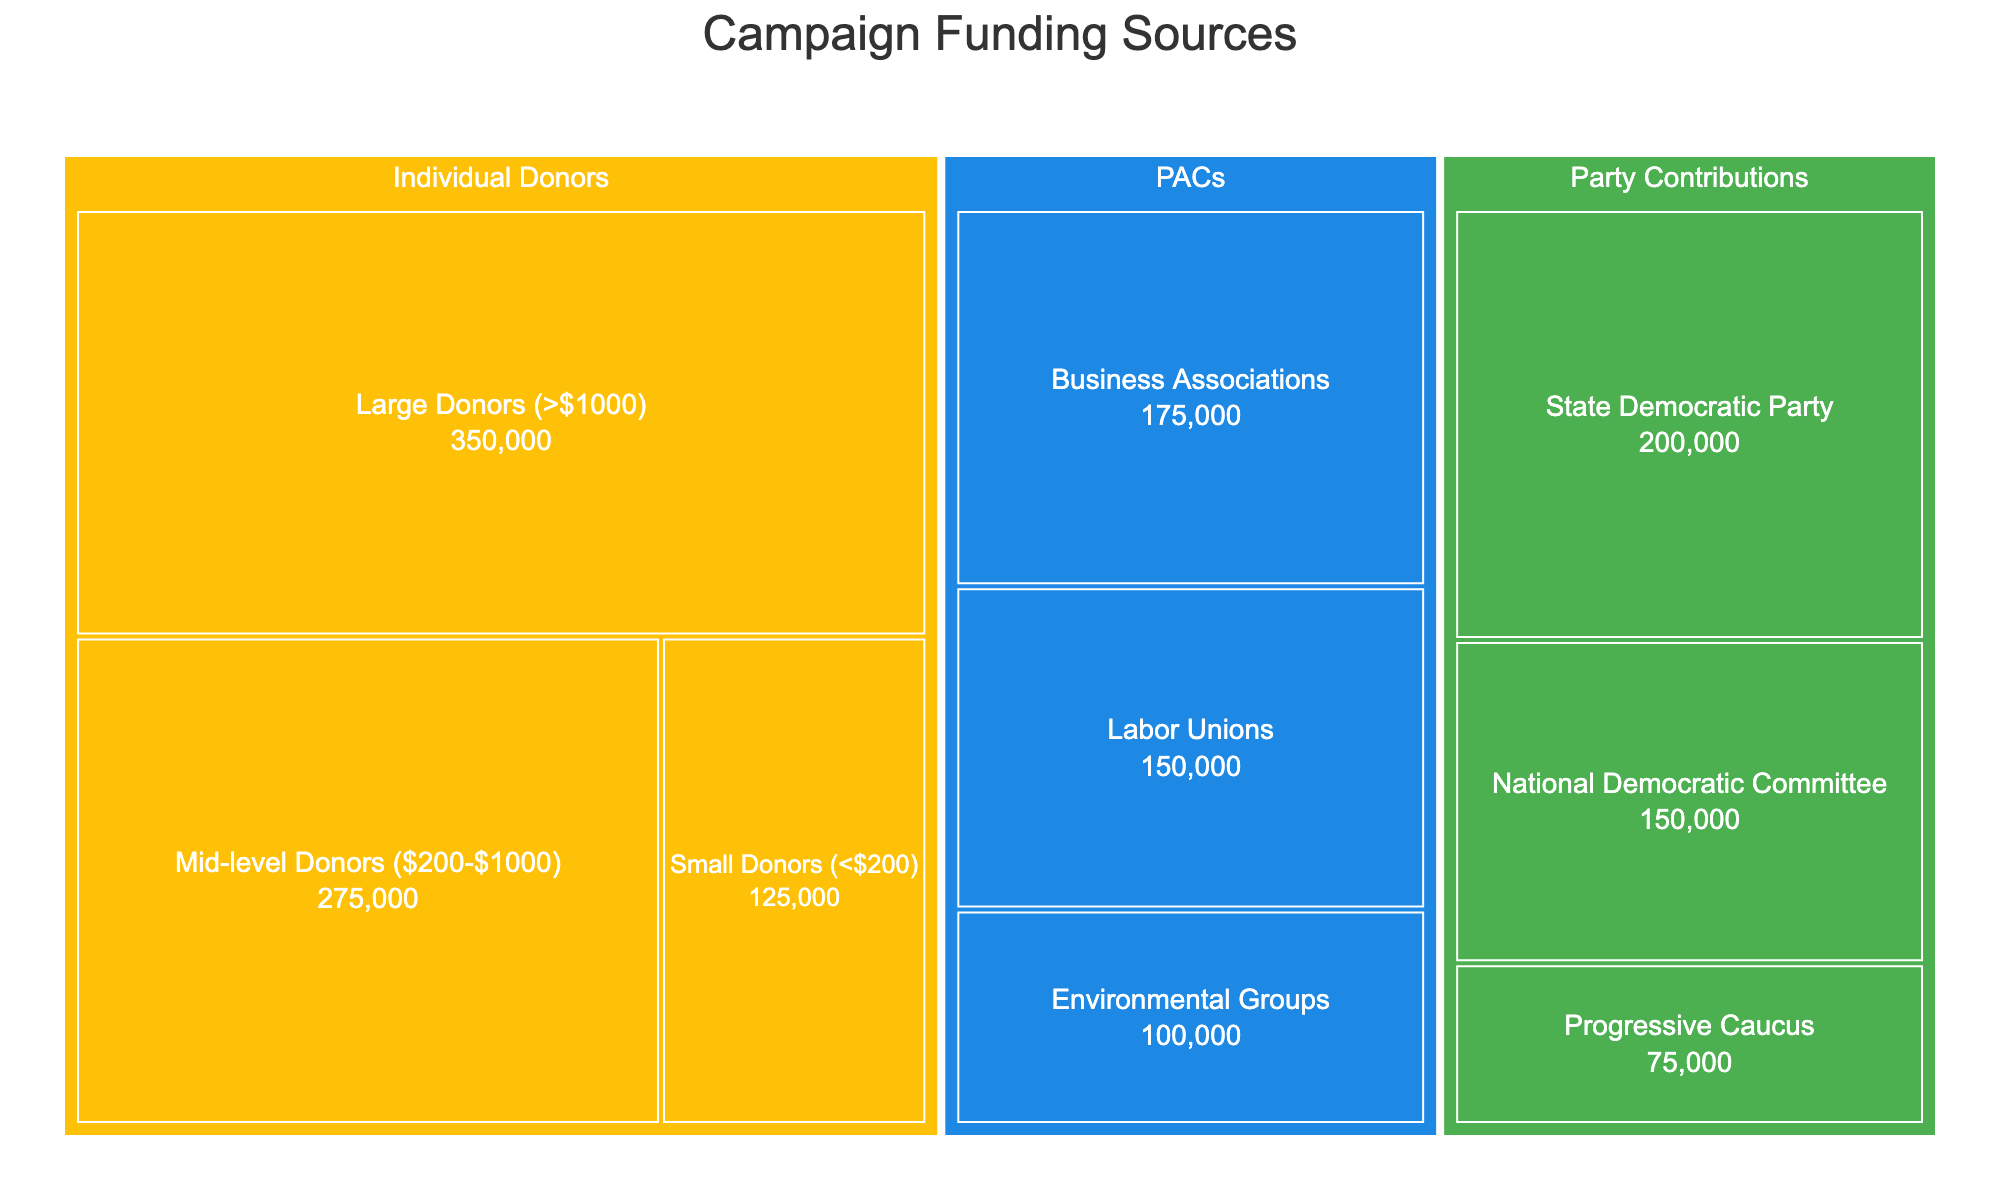Which category has the highest total funding? Summing the amounts in each category:
Individual Donors: 125000 + 275000 + 350000 = 750000
PACs: 150000 + 100000 + 175000 = 425000
Party Contributions: 200000 + 150000 + 75000 = 425000
Individual Donors have the highest total funding.
Answer: Individual Donors How much funding does the subcategory with the lowest amount receive? The subcategories and their amounts are:
Small Donors (<$200): 125000
Mid-level Donors ($200-$1000): 275000
Large Donors (>$1000): 350000
Labor Unions: 150000
Environmental Groups: 100000
Business Associations: 175000
State Democratic Party: 200000
National Democratic Committee: 150000
Progressive Caucus: 75000
Environmental Groups receive the lowest amount, which is $75,000.
Answer: $75,000 What is the combined funding from PACs and Party Contributions categories? Sum the totals for PACs and Party Contributions:
PACs: 150000 + 100000 + 175000 = 425000
Party Contributions: 200000 + 150000 + 75000 = 425000
Add these together: 425000 + 425000 = 850000.
Answer: $850,000 Which PAC subcategory contributes the most? The subcategories and their amounts are:
Labor Unions: 150000
Environmental Groups: 100000
Business Associations: 175000
Business Associations is the PAC subcategory that contributes the most at $175,000.
Answer: Business Associations How does the combined amount from Individual Donors compare to total Party Contributions? Total Individual Donors: 125000 + 275000 + 350000 = 750000
Party Contributions: 200000 + 150000 + 75000 = 425000
Individual Donors have more funding: 750000 > 425000
Answer: Individual Donors have more funding What's the proportion of State Democratic Party contributions to total Party Contributions? State Democratic Party: 200000
Total Party Contributions: 200000 + 150000 + 75000 = 425000
Proportion: 200000 / 425000 ≈ 0.471 or 47.1%
Answer: 47.1% If we combine Small and Mid-level Individual Donors, what would their total amount be? Small Donors: 125000
Mid-level Donors: 275000
Combined: 125000 + 275000 = 400000
Answer: $400,000 Which category has the smallest individual subcategory contribution? The smallest subcategory contribution from each category:
Individual Donors: Small Donors ($125,000)
PACs: Environmental Groups ($100,000)
Party Contributions: Progressive Caucus ($75,000)
The smallest individual subcategory contribution is from the Progressive Caucus.
Answer: Progressive Caucus What's the funding difference between Large Donors and Business Associations? Large Donors: 350000
Business Associations: 175000
Difference: 350000 - 175000 = 175000
Answer: $175,000 What percentage of total campaign funding comes from Party Contributions? Total funding:
Individual Donors: 125000 + 275000 + 350000 = 750000
PACs: 150000 + 100000 + 175000 = 425000
Party Contributions: 200000 + 150000 + 75000 = 425000
Total campaign funding: 750000 + 425000 + 425000 = 1600000
Party Contributions share: (425000 / 1600000) * 100 ≈ 26.6%
Answer: 26.6% 